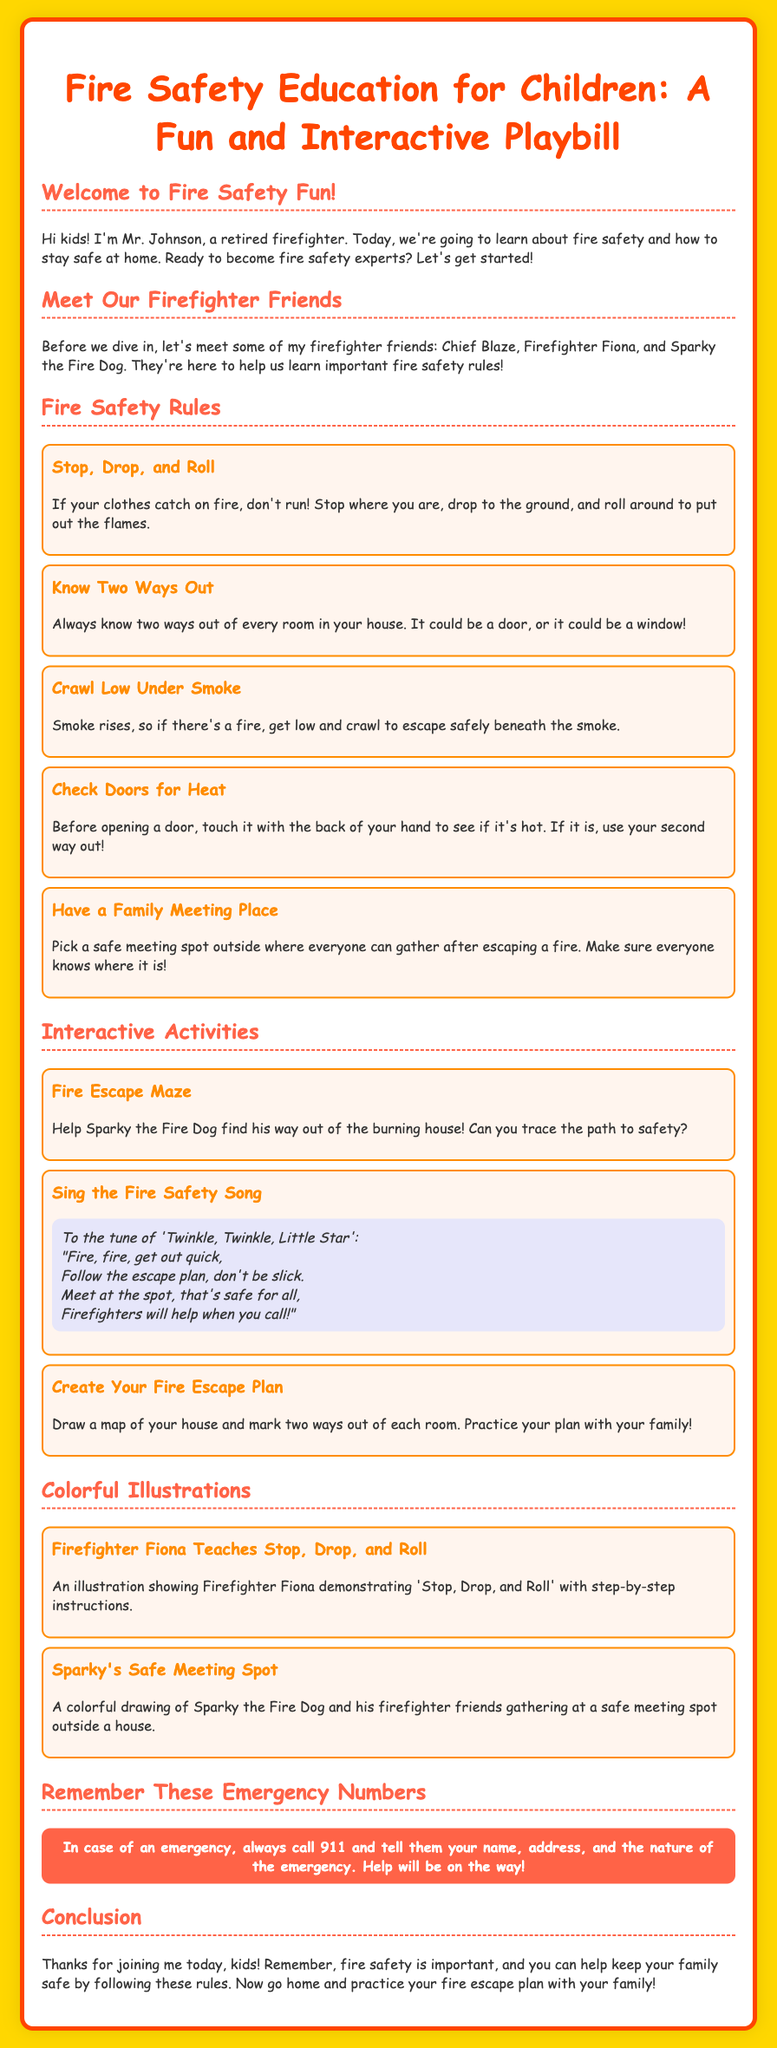What is the title of the playbill? The title is found at the top of the document.
Answer: Fire Safety Education for Children: A Fun and Interactive Playbill Who introduces the fire safety session? The introduction includes the character who welcomes the children.
Answer: Mr. Johnson What is one of the fire safety rules? This question asks for a specific rule mentioned in the document.
Answer: Stop, Drop, and Roll How many firefighter friends are mentioned? The text states the number of characters introduced as friends.
Answer: Three What does the fire safety song follow the tune of? The song included in the activities is based on a well-known children's tune.
Answer: Twinkle, Twinkle, Little Star What should you do before opening a door? This is a specific action recommended in the fire safety rules.
Answer: Check for heat What activity involves helping Sparky? This question focuses on identifying one of the interactive activities listed.
Answer: Fire Escape Maze What color is the background of the playbill? The background color of the playbill is specified in the styling.
Answer: Gold What emergency number should you call? The document clearly states the emergency contact number to remember.
Answer: 911 